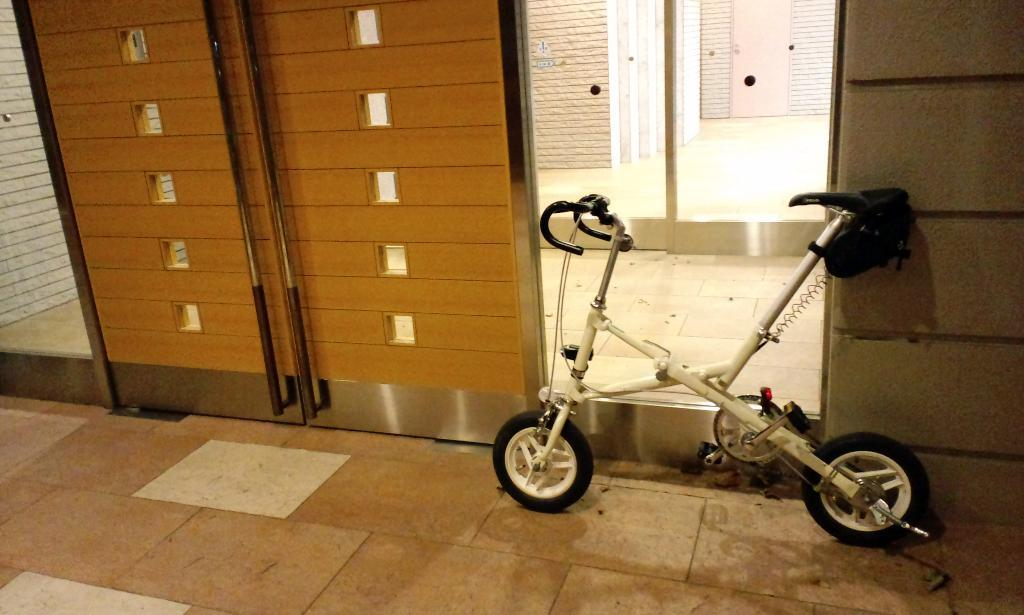What object is on the floor in the image? There is a small bicycle on the floor. What type of structure can be seen in the image? There is a wall in the image. Is there any entrance or exit visible in the image? Yes, there is a door in the image. What color is the crayon that the zebra is holding in the image? There is no crayon or zebra present in the image. What type of powder is being used to clean the bicycle in the image? There is no powder or cleaning activity depicted in the image. 